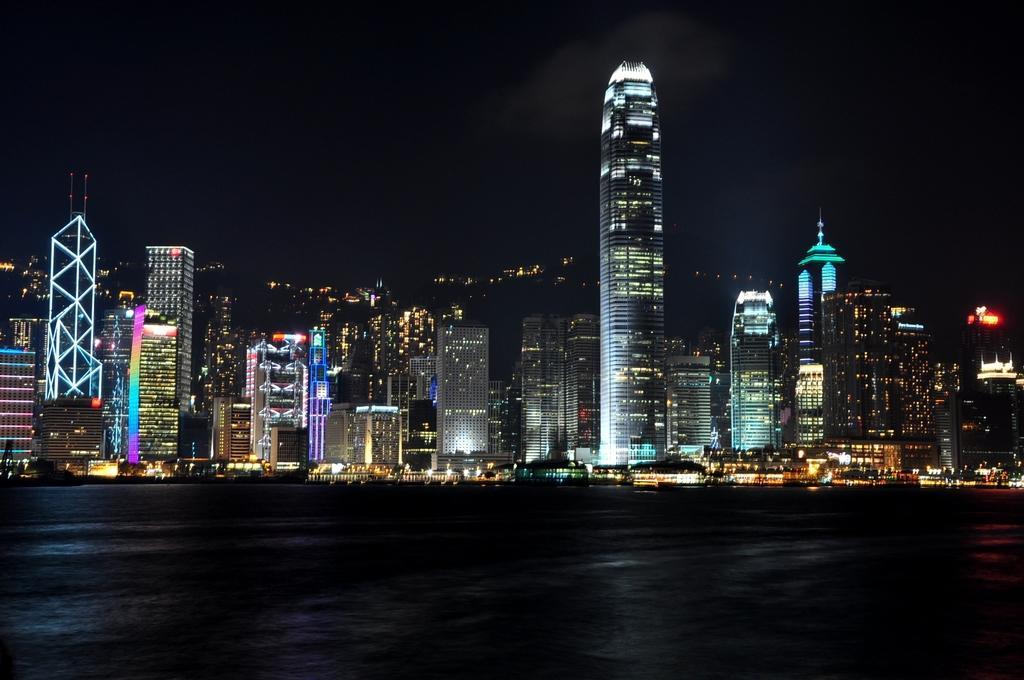Please provide a concise description of this image. In this image we can see few buildings with lights and in front of the buildings there is water. 